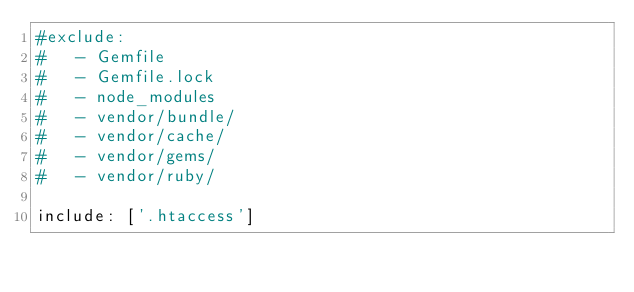<code> <loc_0><loc_0><loc_500><loc_500><_YAML_>#exclude:
#   - Gemfile
#   - Gemfile.lock
#   - node_modules
#   - vendor/bundle/
#   - vendor/cache/
#   - vendor/gems/
#   - vendor/ruby/

include: ['.htaccess']
</code> 